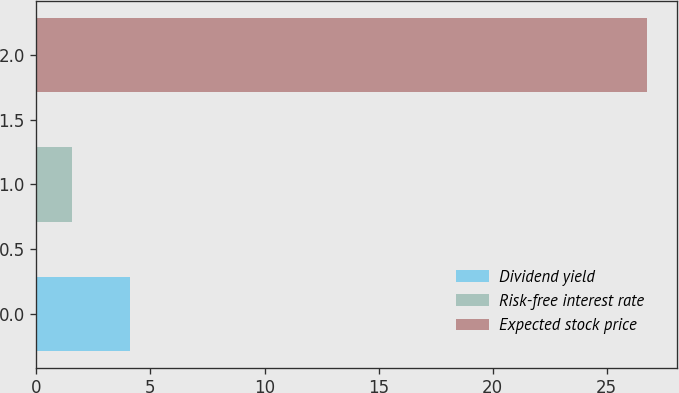Convert chart to OTSL. <chart><loc_0><loc_0><loc_500><loc_500><bar_chart><fcel>Dividend yield<fcel>Risk-free interest rate<fcel>Expected stock price<nl><fcel>4.09<fcel>1.57<fcel>26.76<nl></chart> 